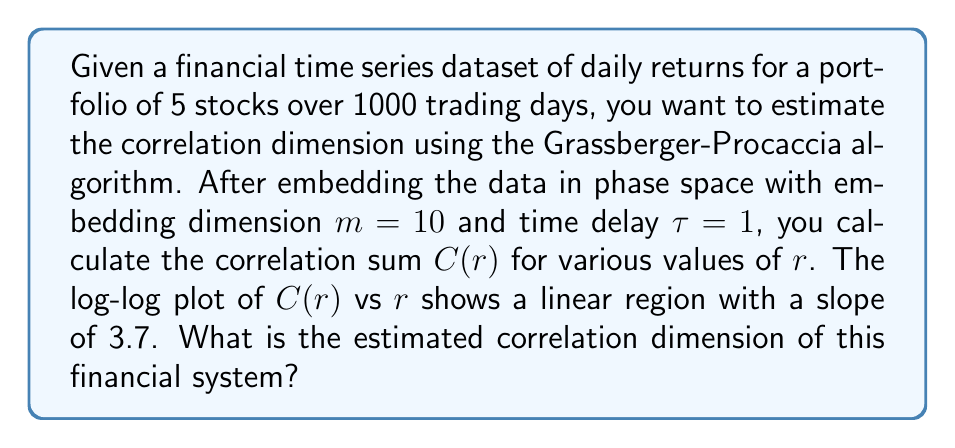Solve this math problem. To estimate the correlation dimension using the Grassberger-Procaccia algorithm, we follow these steps:

1. Embed the time series data in phase space:
   - Embedding dimension $m = 10$
   - Time delay $\tau = 1$

2. Calculate the correlation sum $C(r)$ for various values of $r$:
   $$C(r) = \frac{2}{N(N-1)} \sum_{i=1}^{N} \sum_{j=i+1}^{N} \Theta(r - \|\mathbf{x}_i - \mathbf{x}_j\|)$$
   where $N$ is the number of points, $\Theta$ is the Heaviside step function, and $\mathbf{x}_i$ are the embedded vectors.

3. Create a log-log plot of $C(r)$ vs $r$.

4. Identify the linear region in the log-log plot.

5. Calculate the slope of the linear region:
   Given slope = 3.7

6. The correlation dimension $D_2$ is equal to this slope:
   $$D_2 = \lim_{r \to 0} \frac{\log C(r)}{\log r} = 3.7$$

Therefore, the estimated correlation dimension of the financial system is 3.7.
Answer: 3.7 